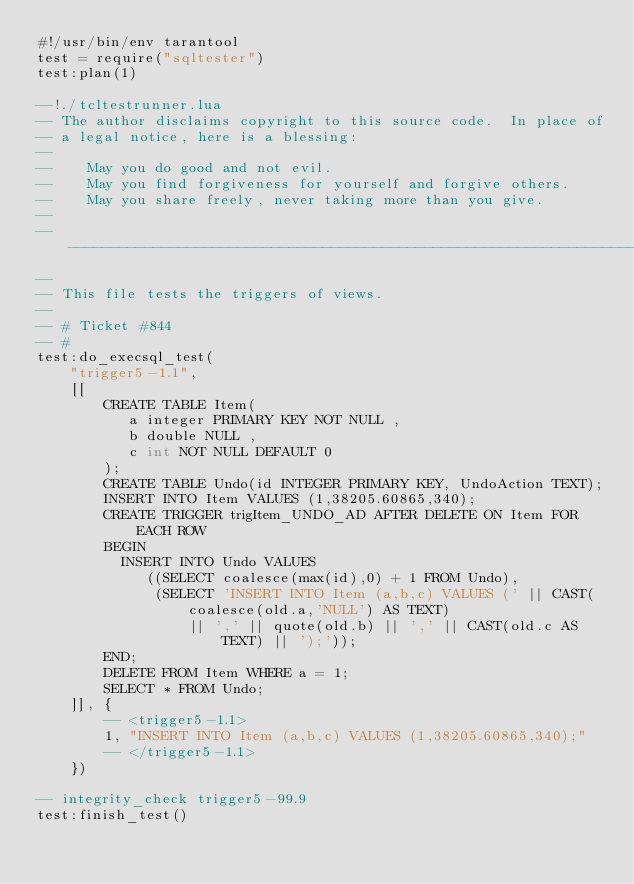<code> <loc_0><loc_0><loc_500><loc_500><_Lua_>#!/usr/bin/env tarantool
test = require("sqltester")
test:plan(1)

--!./tcltestrunner.lua
-- The author disclaims copyright to this source code.  In place of
-- a legal notice, here is a blessing:
--
--    May you do good and not evil.
--    May you find forgiveness for yourself and forgive others.
--    May you share freely, never taking more than you give.
--
-------------------------------------------------------------------------
--
-- This file tests the triggers of views.
--
-- # Ticket #844
-- #
test:do_execsql_test(
    "trigger5-1.1",
    [[
        CREATE TABLE Item(
           a integer PRIMARY KEY NOT NULL ,
           b double NULL ,
           c int NOT NULL DEFAULT 0
        );
        CREATE TABLE Undo(id INTEGER PRIMARY KEY, UndoAction TEXT);
        INSERT INTO Item VALUES (1,38205.60865,340);
        CREATE TRIGGER trigItem_UNDO_AD AFTER DELETE ON Item FOR EACH ROW
        BEGIN
          INSERT INTO Undo VALUES
             ((SELECT coalesce(max(id),0) + 1 FROM Undo),
              (SELECT 'INSERT INTO Item (a,b,c) VALUES (' || CAST(coalesce(old.a,'NULL') AS TEXT)
                  || ',' || quote(old.b) || ',' || CAST(old.c AS TEXT) || ');'));
        END;
        DELETE FROM Item WHERE a = 1;
        SELECT * FROM Undo;
    ]], {
        -- <trigger5-1.1>
        1, "INSERT INTO Item (a,b,c) VALUES (1,38205.60865,340);"
        -- </trigger5-1.1>
    })

-- integrity_check trigger5-99.9
test:finish_test()
</code> 